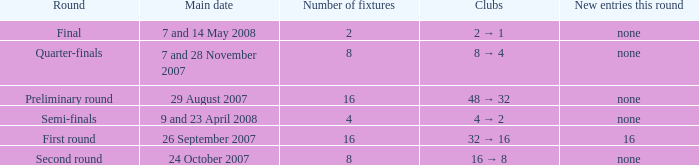Would you mind parsing the complete table? {'header': ['Round', 'Main date', 'Number of fixtures', 'Clubs', 'New entries this round'], 'rows': [['Final', '7 and 14 May 2008', '2', '2 → 1', 'none'], ['Quarter-finals', '7 and 28 November 2007', '8', '8 → 4', 'none'], ['Preliminary round', '29 August 2007', '16', '48 → 32', 'none'], ['Semi-finals', '9 and 23 April 2008', '4', '4 → 2', 'none'], ['First round', '26 September 2007', '16', '32 → 16', '16'], ['Second round', '24 October 2007', '8', '16 → 8', 'none']]} What is the Round when the number of fixtures is more than 2, and the Main date of 7 and 28 november 2007? Quarter-finals. 